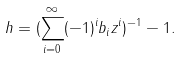Convert formula to latex. <formula><loc_0><loc_0><loc_500><loc_500>h = ( \sum _ { i = 0 } ^ { \infty } ( - 1 ) ^ { i } b _ { i } z ^ { i } ) ^ { - 1 } - 1 .</formula> 